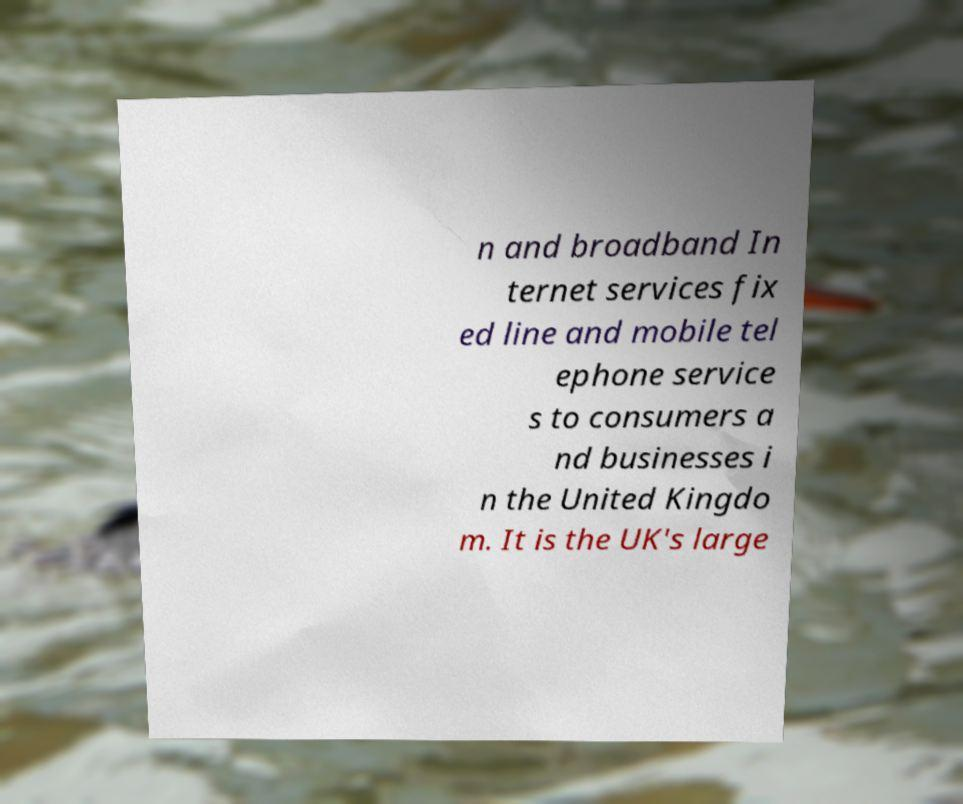I need the written content from this picture converted into text. Can you do that? n and broadband In ternet services fix ed line and mobile tel ephone service s to consumers a nd businesses i n the United Kingdo m. It is the UK's large 